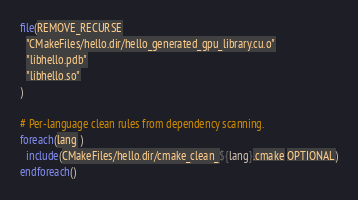<code> <loc_0><loc_0><loc_500><loc_500><_CMake_>file(REMOVE_RECURSE
  "CMakeFiles/hello.dir/hello_generated_gpu_library.cu.o"
  "libhello.pdb"
  "libhello.so"
)

# Per-language clean rules from dependency scanning.
foreach(lang )
  include(CMakeFiles/hello.dir/cmake_clean_${lang}.cmake OPTIONAL)
endforeach()
</code> 